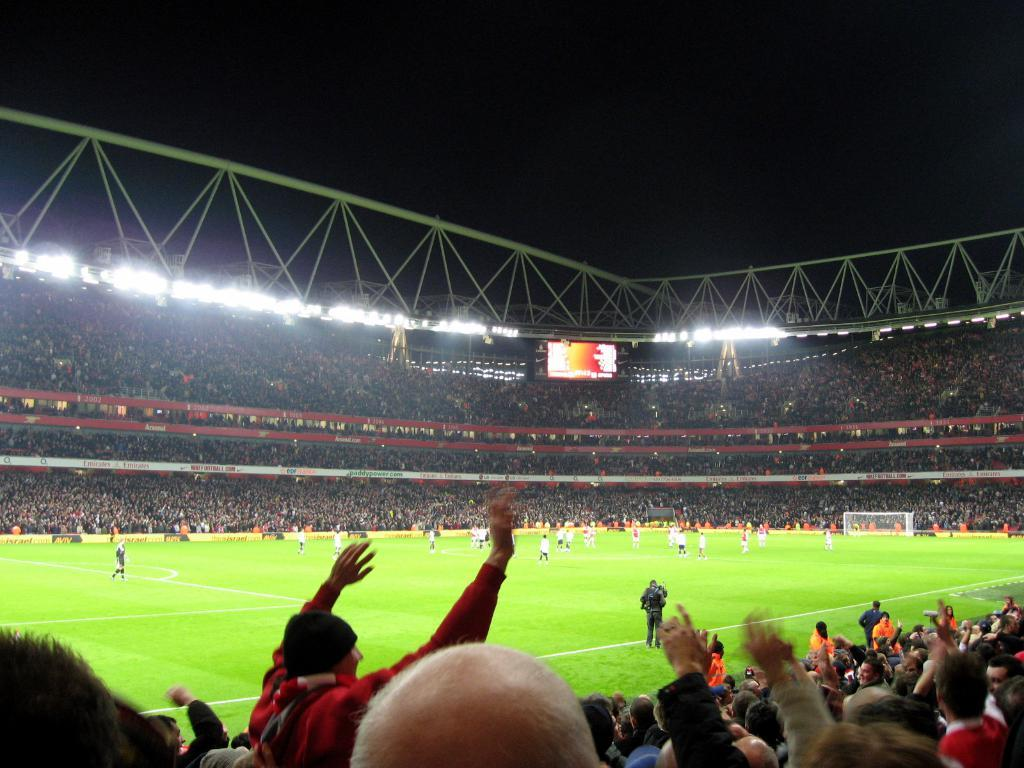What are the players in the image doing? The players in the image are playing on the ground. What can be seen around the ground in the image? People are sitting on chairs around the ground. What is visible at the top of the image? There are flood lights at the top of the image. What type of boot is being rewarded to the players in the image? There is no boot or reward being given to the players in the image; they are simply playing on the ground. 